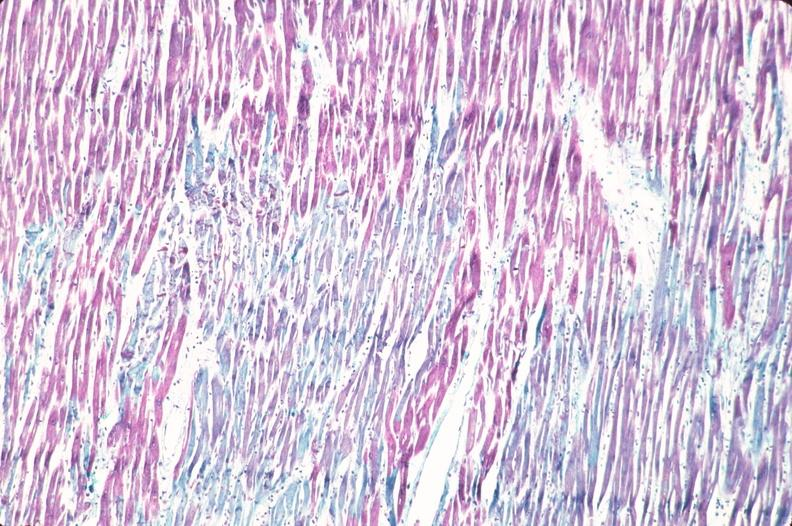do aldehyde fuscin stain?
Answer the question using a single word or phrase. Yes 